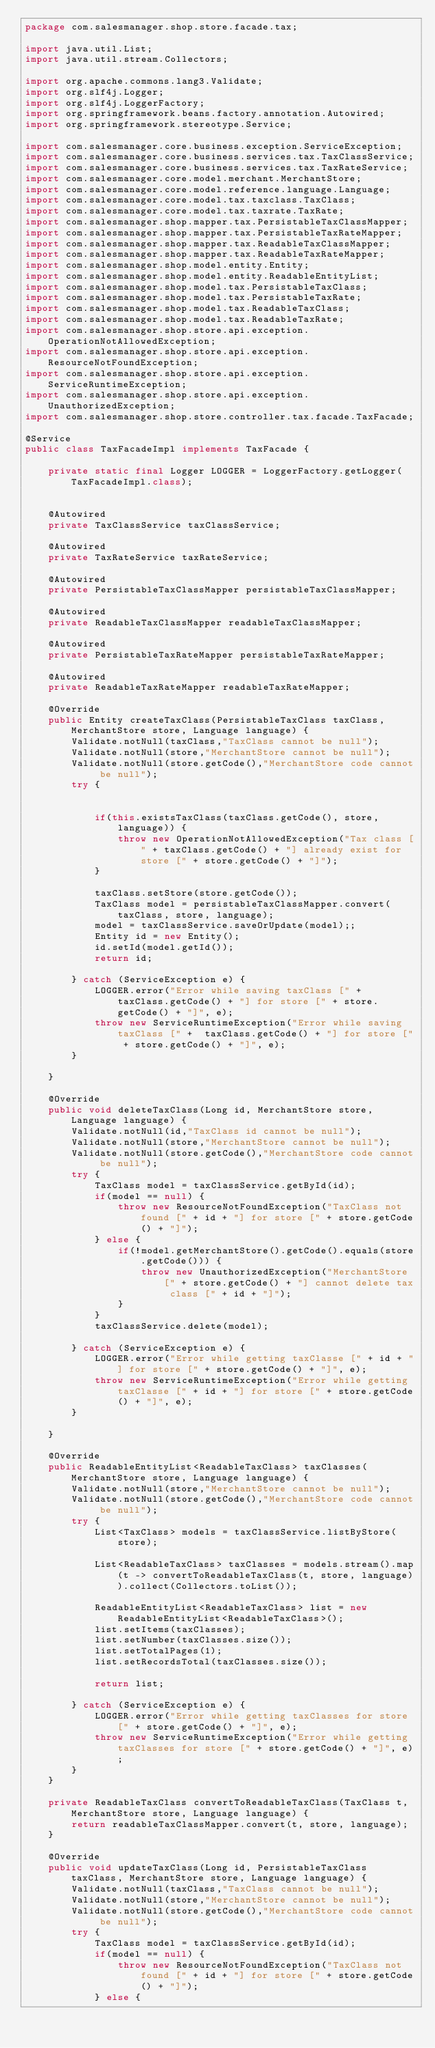Convert code to text. <code><loc_0><loc_0><loc_500><loc_500><_Java_>package com.salesmanager.shop.store.facade.tax;

import java.util.List;
import java.util.stream.Collectors;

import org.apache.commons.lang3.Validate;
import org.slf4j.Logger;
import org.slf4j.LoggerFactory;
import org.springframework.beans.factory.annotation.Autowired;
import org.springframework.stereotype.Service;

import com.salesmanager.core.business.exception.ServiceException;
import com.salesmanager.core.business.services.tax.TaxClassService;
import com.salesmanager.core.business.services.tax.TaxRateService;
import com.salesmanager.core.model.merchant.MerchantStore;
import com.salesmanager.core.model.reference.language.Language;
import com.salesmanager.core.model.tax.taxclass.TaxClass;
import com.salesmanager.core.model.tax.taxrate.TaxRate;
import com.salesmanager.shop.mapper.tax.PersistableTaxClassMapper;
import com.salesmanager.shop.mapper.tax.PersistableTaxRateMapper;
import com.salesmanager.shop.mapper.tax.ReadableTaxClassMapper;
import com.salesmanager.shop.mapper.tax.ReadableTaxRateMapper;
import com.salesmanager.shop.model.entity.Entity;
import com.salesmanager.shop.model.entity.ReadableEntityList;
import com.salesmanager.shop.model.tax.PersistableTaxClass;
import com.salesmanager.shop.model.tax.PersistableTaxRate;
import com.salesmanager.shop.model.tax.ReadableTaxClass;
import com.salesmanager.shop.model.tax.ReadableTaxRate;
import com.salesmanager.shop.store.api.exception.OperationNotAllowedException;
import com.salesmanager.shop.store.api.exception.ResourceNotFoundException;
import com.salesmanager.shop.store.api.exception.ServiceRuntimeException;
import com.salesmanager.shop.store.api.exception.UnauthorizedException;
import com.salesmanager.shop.store.controller.tax.facade.TaxFacade;

@Service
public class TaxFacadeImpl implements TaxFacade {
	
	private static final Logger LOGGER = LoggerFactory.getLogger(TaxFacadeImpl.class);
	
	
	@Autowired
	private TaxClassService taxClassService;
	
	@Autowired
	private TaxRateService taxRateService;
	
	@Autowired
	private PersistableTaxClassMapper persistableTaxClassMapper;
	
	@Autowired
	private ReadableTaxClassMapper readableTaxClassMapper;
	
	@Autowired
	private PersistableTaxRateMapper persistableTaxRateMapper;
	
	@Autowired
	private ReadableTaxRateMapper readableTaxRateMapper;

	@Override
	public Entity createTaxClass(PersistableTaxClass taxClass, MerchantStore store, Language language) {
		Validate.notNull(taxClass,"TaxClass cannot be null");
		Validate.notNull(store,"MerchantStore cannot be null");
		Validate.notNull(store.getCode(),"MerchantStore code cannot be null");
		try {
			
			
			if(this.existsTaxClass(taxClass.getCode(), store, language)) {
				throw new OperationNotAllowedException("Tax class [" + taxClass.getCode() + "] already exist for store [" + store.getCode() + "]");
			}

			taxClass.setStore(store.getCode());
			TaxClass model = persistableTaxClassMapper.convert(taxClass, store, language);
			model = taxClassService.saveOrUpdate(model);;
			Entity id = new Entity();
			id.setId(model.getId());
			return id;

		} catch (ServiceException e) {
			LOGGER.error("Error while saving taxClass [" +  taxClass.getCode() + "] for store [" + store.getCode() + "]", e);
			throw new ServiceRuntimeException("Error while saving taxClass [" +  taxClass.getCode() + "] for store [" + store.getCode() + "]", e);
		}
		
	}

	@Override
	public void deleteTaxClass(Long id, MerchantStore store, Language language) {
		Validate.notNull(id,"TaxClass id cannot be null");
		Validate.notNull(store,"MerchantStore cannot be null");
		Validate.notNull(store.getCode(),"MerchantStore code cannot be null");
		try {
			TaxClass model = taxClassService.getById(id);
			if(model == null) {
				throw new ResourceNotFoundException("TaxClass not found [" + id + "] for store [" + store.getCode() + "]");
			} else {
				if(!model.getMerchantStore().getCode().equals(store.getCode())) {
					throw new UnauthorizedException("MerchantStore [" + store.getCode() + "] cannot delete tax class [" + id + "]");
				}
			}
			taxClassService.delete(model);
				
		} catch (ServiceException e) {
			LOGGER.error("Error while getting taxClasse [" + id + "] for store [" + store.getCode() + "]", e);
			throw new ServiceRuntimeException("Error while getting taxClasse [" + id + "] for store [" + store.getCode() + "]", e);
		}

	}

	@Override
	public ReadableEntityList<ReadableTaxClass> taxClasses(MerchantStore store, Language language) {
		Validate.notNull(store,"MerchantStore cannot be null");
		Validate.notNull(store.getCode(),"MerchantStore code cannot be null");
		try {
			List<TaxClass> models = taxClassService.listByStore(store);
			
			List<ReadableTaxClass> taxClasses = models.stream().map(t -> convertToReadableTaxClass(t, store, language)).collect(Collectors.toList());

			ReadableEntityList<ReadableTaxClass> list = new ReadableEntityList<ReadableTaxClass>();
			list.setItems(taxClasses);
			list.setNumber(taxClasses.size());
			list.setTotalPages(1);
			list.setRecordsTotal(taxClasses.size());
			
			return list;
			
		} catch (ServiceException e) {
			LOGGER.error("Error while getting taxClasses for store [" + store.getCode() + "]", e);
			throw new ServiceRuntimeException("Error while getting taxClasses for store [" + store.getCode() + "]", e);
		}
	}
	
	private ReadableTaxClass convertToReadableTaxClass(TaxClass t, MerchantStore store, Language language) {
		return readableTaxClassMapper.convert(t, store, language);
	}
	
	@Override
	public void updateTaxClass(Long id, PersistableTaxClass taxClass, MerchantStore store, Language language) {
		Validate.notNull(taxClass,"TaxClass cannot be null");
		Validate.notNull(store,"MerchantStore cannot be null");
		Validate.notNull(store.getCode(),"MerchantStore code cannot be null");
		try {
			TaxClass model = taxClassService.getById(id);
			if(model == null) {
				throw new ResourceNotFoundException("TaxClass not found [" + id + "] for store [" + store.getCode() + "]");
			} else {</code> 